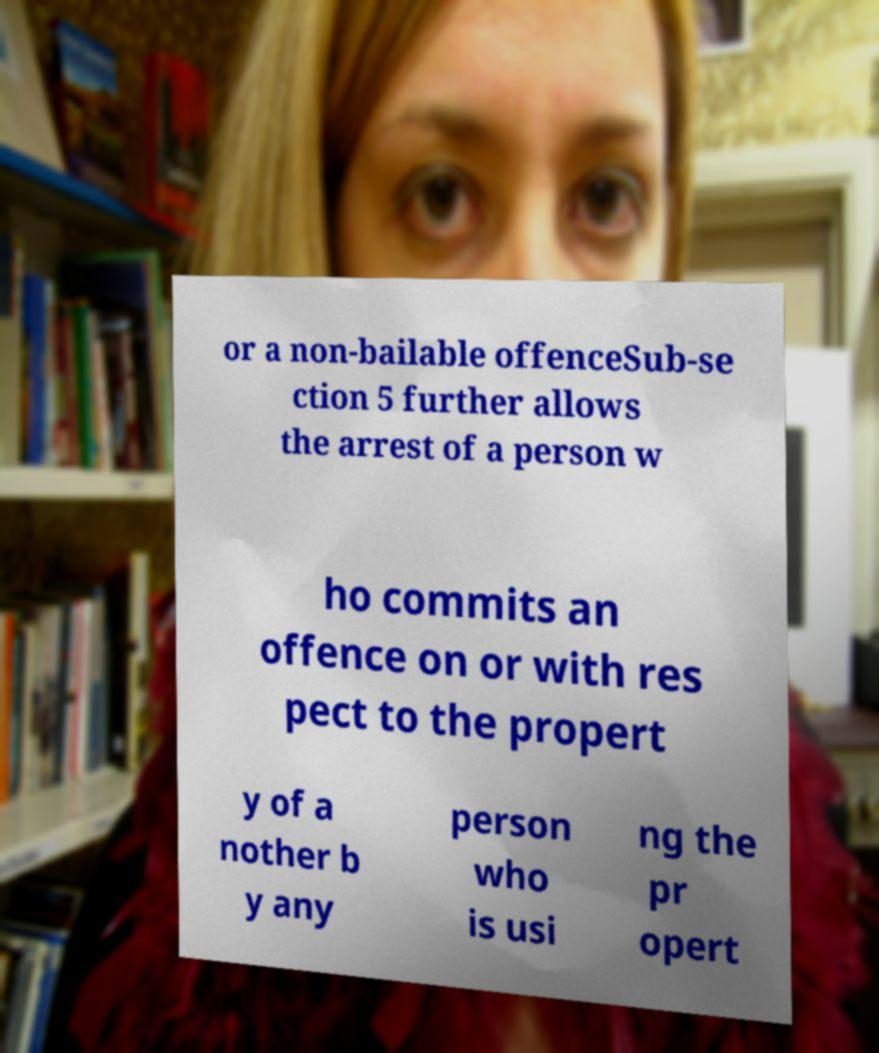For documentation purposes, I need the text within this image transcribed. Could you provide that? or a non-bailable offenceSub-se ction 5 further allows the arrest of a person w ho commits an offence on or with res pect to the propert y of a nother b y any person who is usi ng the pr opert 